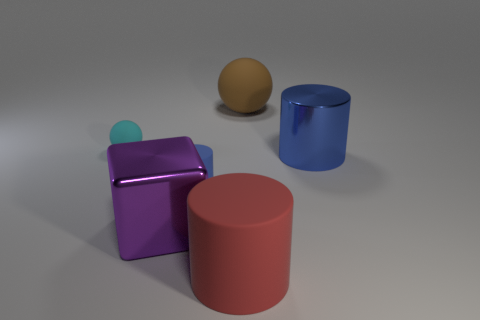Subtract all red cylinders. How many cylinders are left? 2 Add 2 purple cubes. How many objects exist? 8 Subtract all red cylinders. How many cylinders are left? 2 Subtract all blocks. How many objects are left? 5 Subtract 2 cylinders. How many cylinders are left? 1 Subtract all gray spheres. Subtract all gray cylinders. How many spheres are left? 2 Subtract all brown cubes. How many yellow cylinders are left? 0 Subtract all metal cylinders. Subtract all blue cylinders. How many objects are left? 3 Add 4 large brown spheres. How many large brown spheres are left? 5 Add 3 large blue things. How many large blue things exist? 4 